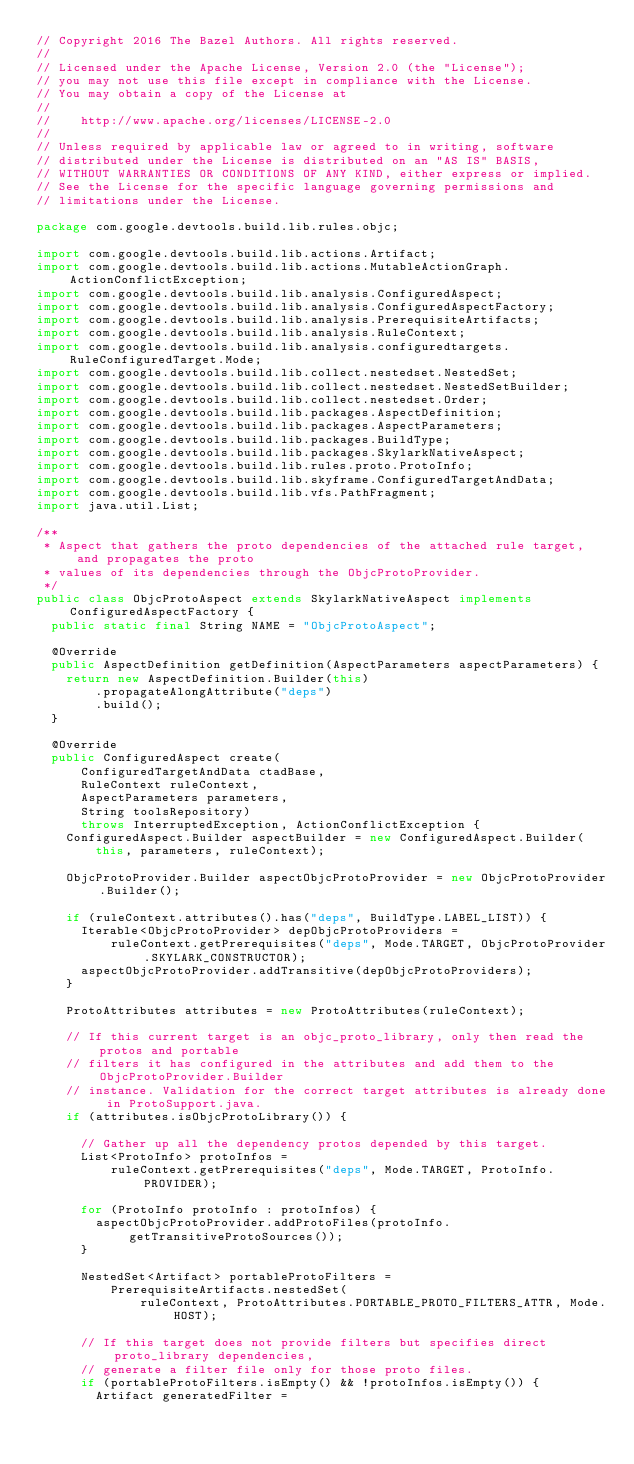Convert code to text. <code><loc_0><loc_0><loc_500><loc_500><_Java_>// Copyright 2016 The Bazel Authors. All rights reserved.
//
// Licensed under the Apache License, Version 2.0 (the "License");
// you may not use this file except in compliance with the License.
// You may obtain a copy of the License at
//
//    http://www.apache.org/licenses/LICENSE-2.0
//
// Unless required by applicable law or agreed to in writing, software
// distributed under the License is distributed on an "AS IS" BASIS,
// WITHOUT WARRANTIES OR CONDITIONS OF ANY KIND, either express or implied.
// See the License for the specific language governing permissions and
// limitations under the License.

package com.google.devtools.build.lib.rules.objc;

import com.google.devtools.build.lib.actions.Artifact;
import com.google.devtools.build.lib.actions.MutableActionGraph.ActionConflictException;
import com.google.devtools.build.lib.analysis.ConfiguredAspect;
import com.google.devtools.build.lib.analysis.ConfiguredAspectFactory;
import com.google.devtools.build.lib.analysis.PrerequisiteArtifacts;
import com.google.devtools.build.lib.analysis.RuleContext;
import com.google.devtools.build.lib.analysis.configuredtargets.RuleConfiguredTarget.Mode;
import com.google.devtools.build.lib.collect.nestedset.NestedSet;
import com.google.devtools.build.lib.collect.nestedset.NestedSetBuilder;
import com.google.devtools.build.lib.collect.nestedset.Order;
import com.google.devtools.build.lib.packages.AspectDefinition;
import com.google.devtools.build.lib.packages.AspectParameters;
import com.google.devtools.build.lib.packages.BuildType;
import com.google.devtools.build.lib.packages.SkylarkNativeAspect;
import com.google.devtools.build.lib.rules.proto.ProtoInfo;
import com.google.devtools.build.lib.skyframe.ConfiguredTargetAndData;
import com.google.devtools.build.lib.vfs.PathFragment;
import java.util.List;

/**
 * Aspect that gathers the proto dependencies of the attached rule target, and propagates the proto
 * values of its dependencies through the ObjcProtoProvider.
 */
public class ObjcProtoAspect extends SkylarkNativeAspect implements ConfiguredAspectFactory {
  public static final String NAME = "ObjcProtoAspect";

  @Override
  public AspectDefinition getDefinition(AspectParameters aspectParameters) {
    return new AspectDefinition.Builder(this)
        .propagateAlongAttribute("deps")
        .build();
  }

  @Override
  public ConfiguredAspect create(
      ConfiguredTargetAndData ctadBase,
      RuleContext ruleContext,
      AspectParameters parameters,
      String toolsRepository)
      throws InterruptedException, ActionConflictException {
    ConfiguredAspect.Builder aspectBuilder = new ConfiguredAspect.Builder(
        this, parameters, ruleContext);

    ObjcProtoProvider.Builder aspectObjcProtoProvider = new ObjcProtoProvider.Builder();

    if (ruleContext.attributes().has("deps", BuildType.LABEL_LIST)) {
      Iterable<ObjcProtoProvider> depObjcProtoProviders =
          ruleContext.getPrerequisites("deps", Mode.TARGET, ObjcProtoProvider.SKYLARK_CONSTRUCTOR);
      aspectObjcProtoProvider.addTransitive(depObjcProtoProviders);
    }

    ProtoAttributes attributes = new ProtoAttributes(ruleContext);

    // If this current target is an objc_proto_library, only then read the protos and portable
    // filters it has configured in the attributes and add them to the ObjcProtoProvider.Builder
    // instance. Validation for the correct target attributes is already done in ProtoSupport.java.
    if (attributes.isObjcProtoLibrary()) {

      // Gather up all the dependency protos depended by this target.
      List<ProtoInfo> protoInfos =
          ruleContext.getPrerequisites("deps", Mode.TARGET, ProtoInfo.PROVIDER);

      for (ProtoInfo protoInfo : protoInfos) {
        aspectObjcProtoProvider.addProtoFiles(protoInfo.getTransitiveProtoSources());
      }

      NestedSet<Artifact> portableProtoFilters =
          PrerequisiteArtifacts.nestedSet(
              ruleContext, ProtoAttributes.PORTABLE_PROTO_FILTERS_ATTR, Mode.HOST);

      // If this target does not provide filters but specifies direct proto_library dependencies,
      // generate a filter file only for those proto files.
      if (portableProtoFilters.isEmpty() && !protoInfos.isEmpty()) {
        Artifact generatedFilter =</code> 